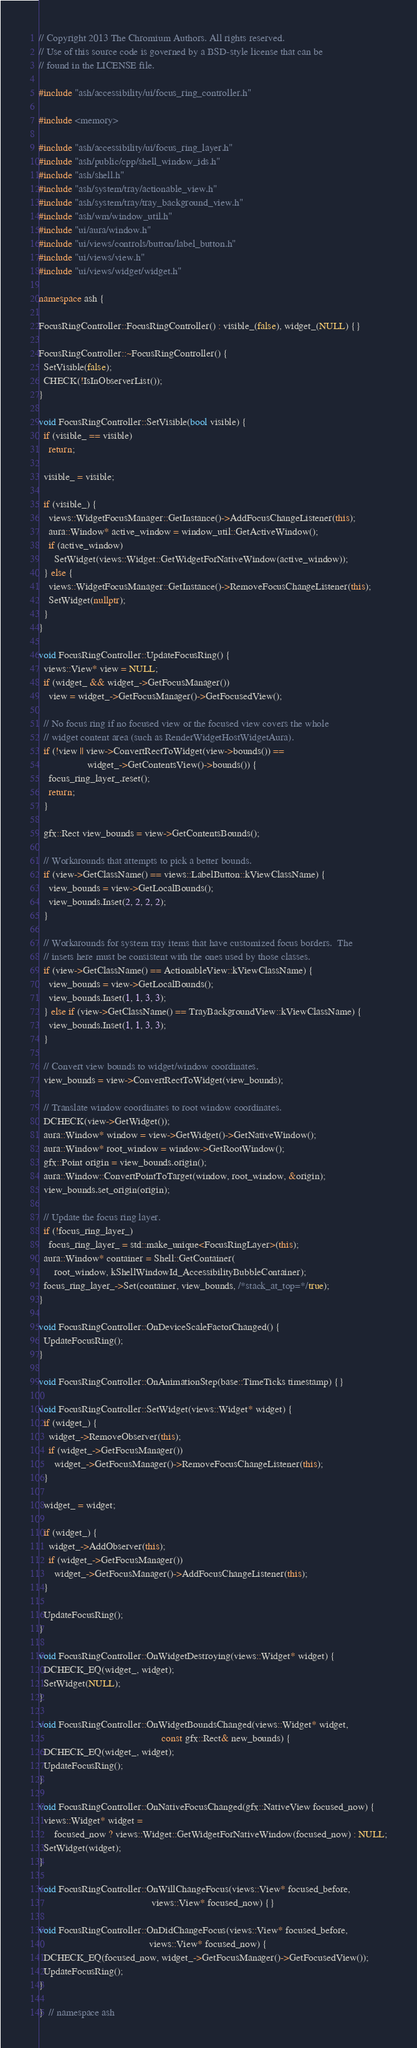<code> <loc_0><loc_0><loc_500><loc_500><_C++_>// Copyright 2013 The Chromium Authors. All rights reserved.
// Use of this source code is governed by a BSD-style license that can be
// found in the LICENSE file.

#include "ash/accessibility/ui/focus_ring_controller.h"

#include <memory>

#include "ash/accessibility/ui/focus_ring_layer.h"
#include "ash/public/cpp/shell_window_ids.h"
#include "ash/shell.h"
#include "ash/system/tray/actionable_view.h"
#include "ash/system/tray/tray_background_view.h"
#include "ash/wm/window_util.h"
#include "ui/aura/window.h"
#include "ui/views/controls/button/label_button.h"
#include "ui/views/view.h"
#include "ui/views/widget/widget.h"

namespace ash {

FocusRingController::FocusRingController() : visible_(false), widget_(NULL) {}

FocusRingController::~FocusRingController() {
  SetVisible(false);
  CHECK(!IsInObserverList());
}

void FocusRingController::SetVisible(bool visible) {
  if (visible_ == visible)
    return;

  visible_ = visible;

  if (visible_) {
    views::WidgetFocusManager::GetInstance()->AddFocusChangeListener(this);
    aura::Window* active_window = window_util::GetActiveWindow();
    if (active_window)
      SetWidget(views::Widget::GetWidgetForNativeWindow(active_window));
  } else {
    views::WidgetFocusManager::GetInstance()->RemoveFocusChangeListener(this);
    SetWidget(nullptr);
  }
}

void FocusRingController::UpdateFocusRing() {
  views::View* view = NULL;
  if (widget_ && widget_->GetFocusManager())
    view = widget_->GetFocusManager()->GetFocusedView();

  // No focus ring if no focused view or the focused view covers the whole
  // widget content area (such as RenderWidgetHostWidgetAura).
  if (!view || view->ConvertRectToWidget(view->bounds()) ==
                   widget_->GetContentsView()->bounds()) {
    focus_ring_layer_.reset();
    return;
  }

  gfx::Rect view_bounds = view->GetContentsBounds();

  // Workarounds that attempts to pick a better bounds.
  if (view->GetClassName() == views::LabelButton::kViewClassName) {
    view_bounds = view->GetLocalBounds();
    view_bounds.Inset(2, 2, 2, 2);
  }

  // Workarounds for system tray items that have customized focus borders.  The
  // insets here must be consistent with the ones used by those classes.
  if (view->GetClassName() == ActionableView::kViewClassName) {
    view_bounds = view->GetLocalBounds();
    view_bounds.Inset(1, 1, 3, 3);
  } else if (view->GetClassName() == TrayBackgroundView::kViewClassName) {
    view_bounds.Inset(1, 1, 3, 3);
  }

  // Convert view bounds to widget/window coordinates.
  view_bounds = view->ConvertRectToWidget(view_bounds);

  // Translate window coordinates to root window coordinates.
  DCHECK(view->GetWidget());
  aura::Window* window = view->GetWidget()->GetNativeWindow();
  aura::Window* root_window = window->GetRootWindow();
  gfx::Point origin = view_bounds.origin();
  aura::Window::ConvertPointToTarget(window, root_window, &origin);
  view_bounds.set_origin(origin);

  // Update the focus ring layer.
  if (!focus_ring_layer_)
    focus_ring_layer_ = std::make_unique<FocusRingLayer>(this);
  aura::Window* container = Shell::GetContainer(
      root_window, kShellWindowId_AccessibilityBubbleContainer);
  focus_ring_layer_->Set(container, view_bounds, /*stack_at_top=*/true);
}

void FocusRingController::OnDeviceScaleFactorChanged() {
  UpdateFocusRing();
}

void FocusRingController::OnAnimationStep(base::TimeTicks timestamp) {}

void FocusRingController::SetWidget(views::Widget* widget) {
  if (widget_) {
    widget_->RemoveObserver(this);
    if (widget_->GetFocusManager())
      widget_->GetFocusManager()->RemoveFocusChangeListener(this);
  }

  widget_ = widget;

  if (widget_) {
    widget_->AddObserver(this);
    if (widget_->GetFocusManager())
      widget_->GetFocusManager()->AddFocusChangeListener(this);
  }

  UpdateFocusRing();
}

void FocusRingController::OnWidgetDestroying(views::Widget* widget) {
  DCHECK_EQ(widget_, widget);
  SetWidget(NULL);
}

void FocusRingController::OnWidgetBoundsChanged(views::Widget* widget,
                                                const gfx::Rect& new_bounds) {
  DCHECK_EQ(widget_, widget);
  UpdateFocusRing();
}

void FocusRingController::OnNativeFocusChanged(gfx::NativeView focused_now) {
  views::Widget* widget =
      focused_now ? views::Widget::GetWidgetForNativeWindow(focused_now) : NULL;
  SetWidget(widget);
}

void FocusRingController::OnWillChangeFocus(views::View* focused_before,
                                            views::View* focused_now) {}

void FocusRingController::OnDidChangeFocus(views::View* focused_before,
                                           views::View* focused_now) {
  DCHECK_EQ(focused_now, widget_->GetFocusManager()->GetFocusedView());
  UpdateFocusRing();
}

}  // namespace ash
</code> 